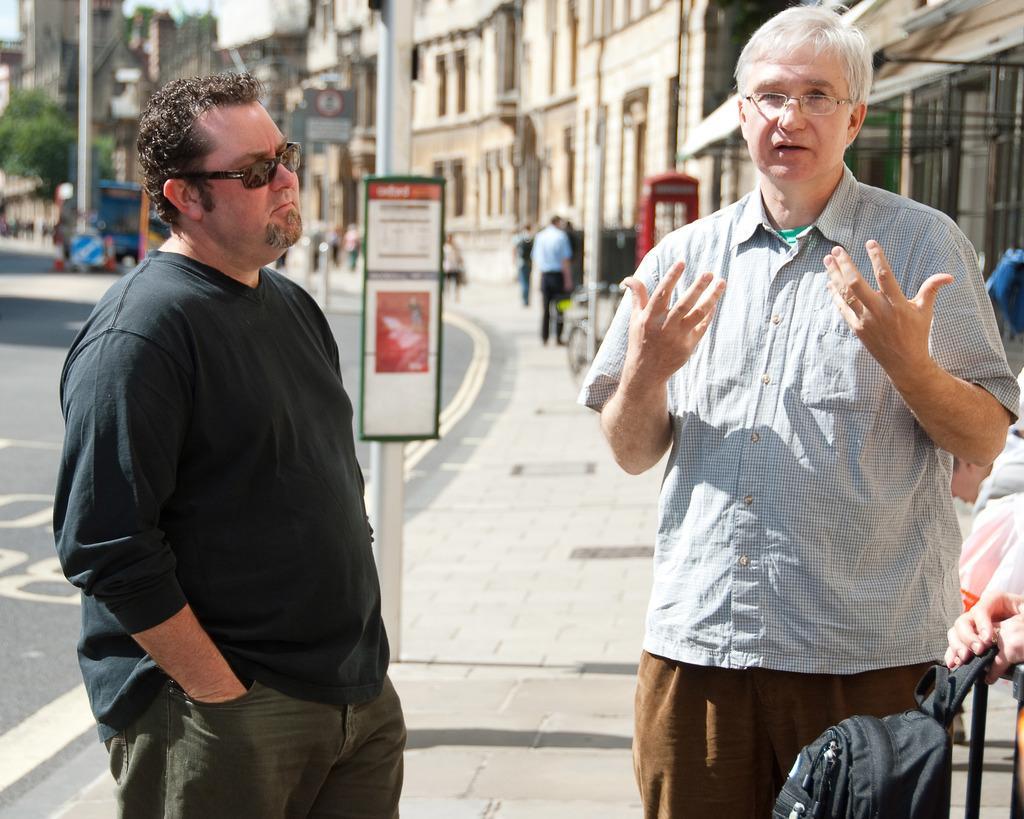Describe this image in one or two sentences. In this picture we can see two men standing here, on the right side there are some buildings, we can see some people in the background, there is a pole and a board here, we can see a bag here, in the background there is a tree. 